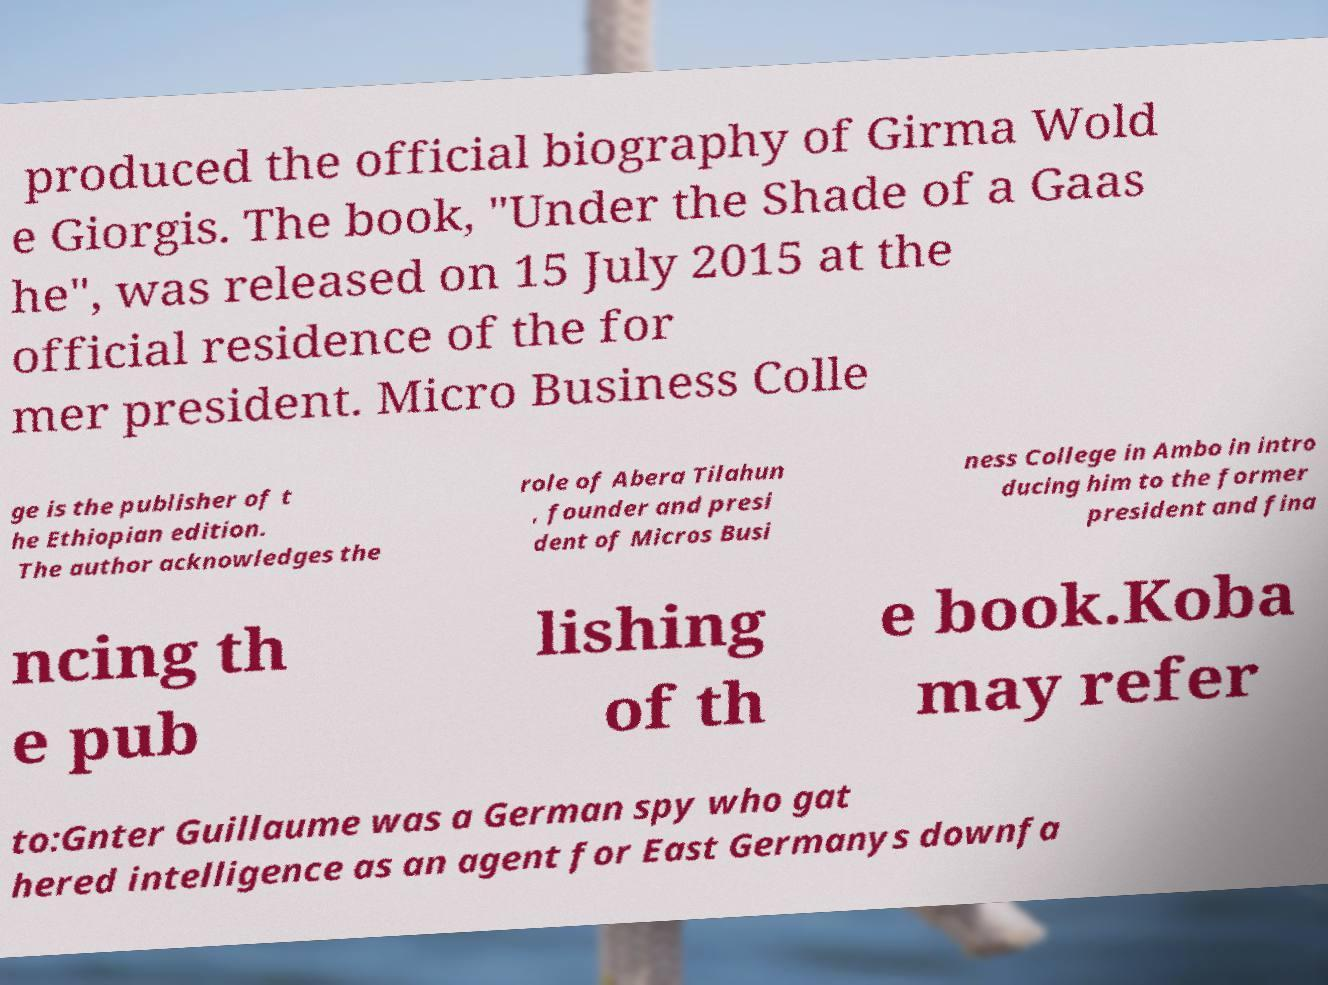I need the written content from this picture converted into text. Can you do that? produced the official biography of Girma Wold e Giorgis. The book, "Under the Shade of a Gaas he", was released on 15 July 2015 at the official residence of the for mer president. Micro Business Colle ge is the publisher of t he Ethiopian edition. The author acknowledges the role of Abera Tilahun , founder and presi dent of Micros Busi ness College in Ambo in intro ducing him to the former president and fina ncing th e pub lishing of th e book.Koba may refer to:Gnter Guillaume was a German spy who gat hered intelligence as an agent for East Germanys downfa 